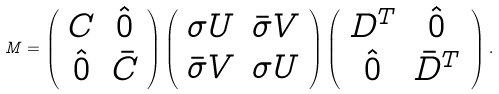Convert formula to latex. <formula><loc_0><loc_0><loc_500><loc_500>{ M } = \left ( \begin{array} { c c } C & \hat { 0 } \\ \hat { 0 } & \bar { C } \end{array} \right ) \left ( \begin{array} { c c } \sigma U & \bar { \sigma } V \\ \bar { \sigma } V & \sigma U \end{array} \right ) \left ( \begin{array} { c c } D ^ { T } & \hat { 0 } \\ \hat { 0 } & \bar { D } ^ { T } \end{array} \, \right ) .</formula> 